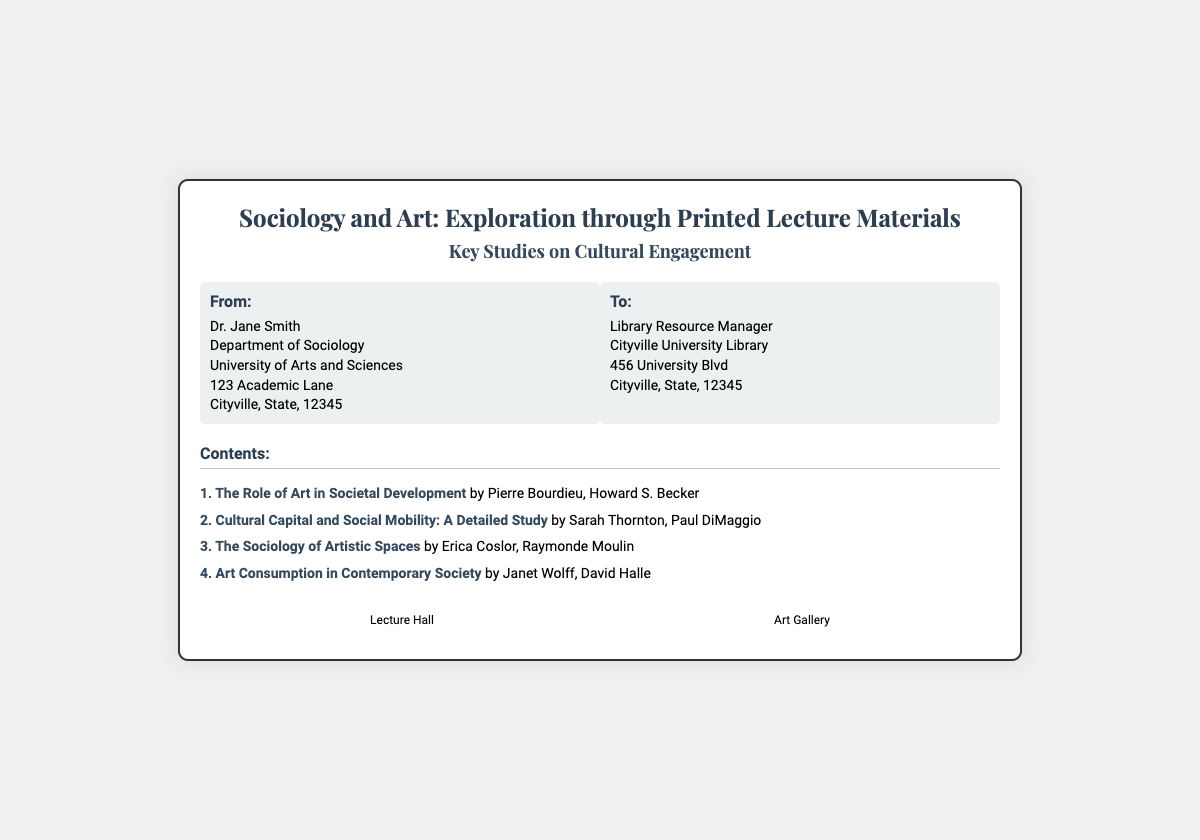What is the title of the document? The title is displayed prominently at the top of the document under the header section.
Answer: Sociology and Art: Exploration through Printed Lecture Materials Who is the sender of the materials? The sender's information is found in the "From" section of the address container.
Answer: Dr. Jane Smith What is the first study listed in the contents? The contents section provides a numbered list of studies, starting with the first item.
Answer: The Role of Art in Societal Development How many content items are listed? The total number of content items is determined by counting the entries in the contents section.
Answer: 4 What university is the recipient affiliated with? The recipient's university is mentioned in their address section.
Answer: Cityville University What type of icons are included in the document? The icons represent specific themes related to the document's content and are labeled below each icon.
Answer: Lecture Hall and Art Gallery Who are the authors of the second study? The authors for each study are listed alongside the study titles in the contents section.
Answer: Sarah Thornton, Paul DiMaggio What is the main theme of the document? The main theme ties together the subject matter discussed in the title and contents.
Answer: Cultural Engagement 